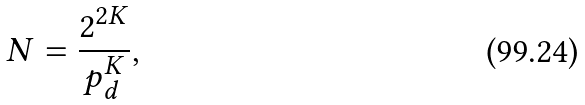Convert formula to latex. <formula><loc_0><loc_0><loc_500><loc_500>N = \frac { 2 ^ { 2 K } } { p _ { d } ^ { K } } ,</formula> 